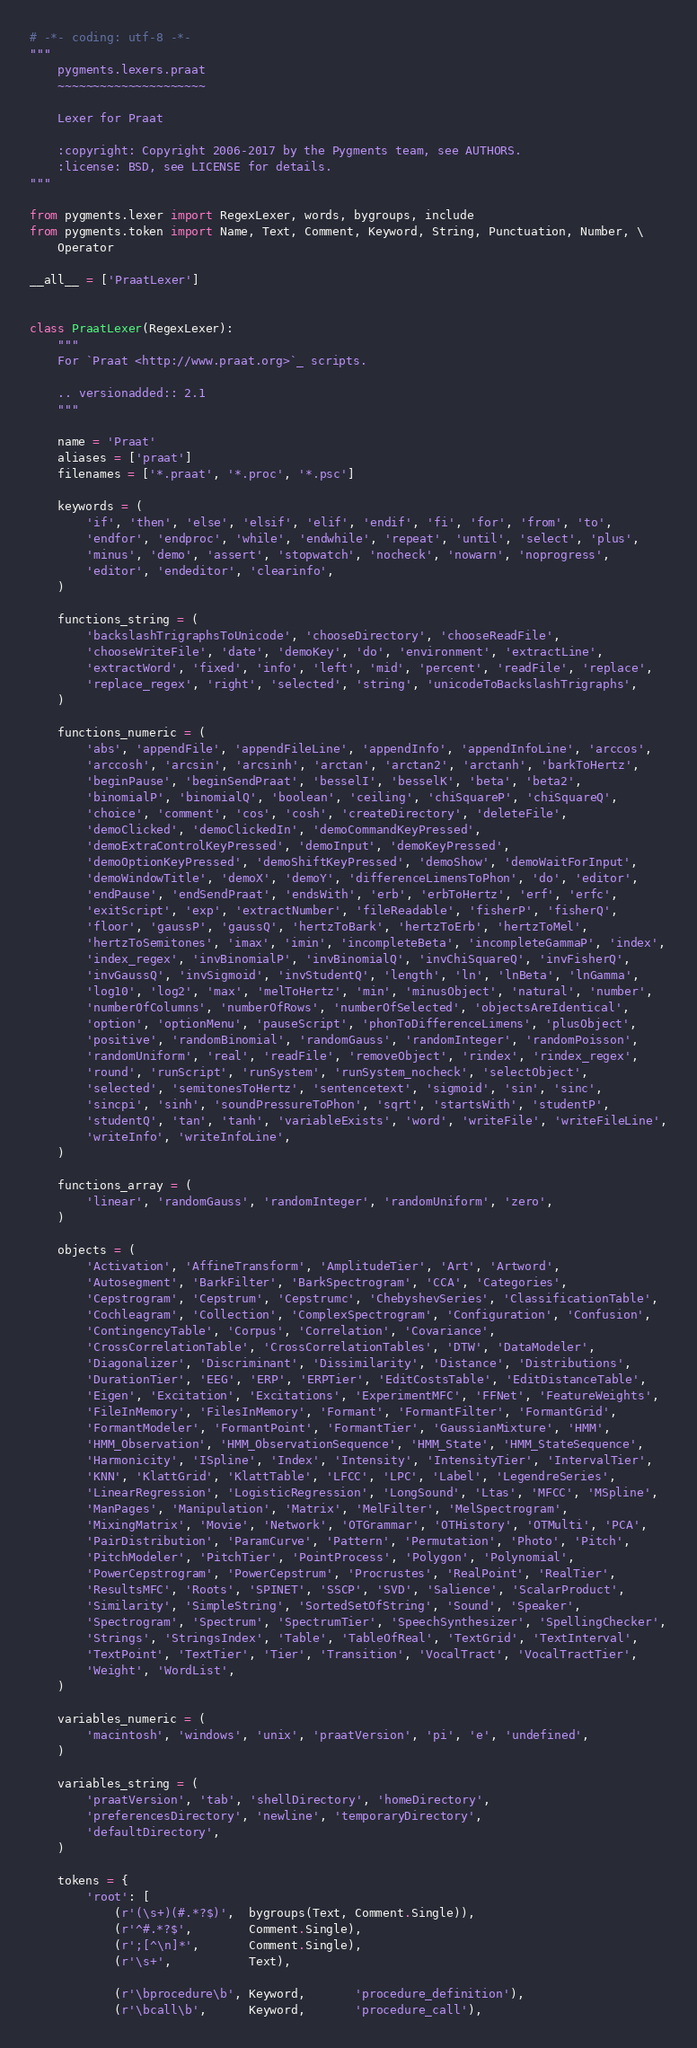Convert code to text. <code><loc_0><loc_0><loc_500><loc_500><_Python_># -*- coding: utf-8 -*-
"""
    pygments.lexers.praat
    ~~~~~~~~~~~~~~~~~~~~~

    Lexer for Praat

    :copyright: Copyright 2006-2017 by the Pygments team, see AUTHORS.
    :license: BSD, see LICENSE for details.
"""

from pygments.lexer import RegexLexer, words, bygroups, include
from pygments.token import Name, Text, Comment, Keyword, String, Punctuation, Number, \
    Operator

__all__ = ['PraatLexer']


class PraatLexer(RegexLexer):
    """
    For `Praat <http://www.praat.org>`_ scripts.

    .. versionadded:: 2.1
    """

    name = 'Praat'
    aliases = ['praat']
    filenames = ['*.praat', '*.proc', '*.psc']

    keywords = (
        'if', 'then', 'else', 'elsif', 'elif', 'endif', 'fi', 'for', 'from', 'to',
        'endfor', 'endproc', 'while', 'endwhile', 'repeat', 'until', 'select', 'plus',
        'minus', 'demo', 'assert', 'stopwatch', 'nocheck', 'nowarn', 'noprogress',
        'editor', 'endeditor', 'clearinfo',
    )

    functions_string = (
        'backslashTrigraphsToUnicode', 'chooseDirectory', 'chooseReadFile',
        'chooseWriteFile', 'date', 'demoKey', 'do', 'environment', 'extractLine',
        'extractWord', 'fixed', 'info', 'left', 'mid', 'percent', 'readFile', 'replace',
        'replace_regex', 'right', 'selected', 'string', 'unicodeToBackslashTrigraphs',
    )

    functions_numeric = (
        'abs', 'appendFile', 'appendFileLine', 'appendInfo', 'appendInfoLine', 'arccos',
        'arccosh', 'arcsin', 'arcsinh', 'arctan', 'arctan2', 'arctanh', 'barkToHertz',
        'beginPause', 'beginSendPraat', 'besselI', 'besselK', 'beta', 'beta2',
        'binomialP', 'binomialQ', 'boolean', 'ceiling', 'chiSquareP', 'chiSquareQ',
        'choice', 'comment', 'cos', 'cosh', 'createDirectory', 'deleteFile',
        'demoClicked', 'demoClickedIn', 'demoCommandKeyPressed',
        'demoExtraControlKeyPressed', 'demoInput', 'demoKeyPressed',
        'demoOptionKeyPressed', 'demoShiftKeyPressed', 'demoShow', 'demoWaitForInput',
        'demoWindowTitle', 'demoX', 'demoY', 'differenceLimensToPhon', 'do', 'editor',
        'endPause', 'endSendPraat', 'endsWith', 'erb', 'erbToHertz', 'erf', 'erfc',
        'exitScript', 'exp', 'extractNumber', 'fileReadable', 'fisherP', 'fisherQ',
        'floor', 'gaussP', 'gaussQ', 'hertzToBark', 'hertzToErb', 'hertzToMel',
        'hertzToSemitones', 'imax', 'imin', 'incompleteBeta', 'incompleteGammaP', 'index',
        'index_regex', 'invBinomialP', 'invBinomialQ', 'invChiSquareQ', 'invFisherQ',
        'invGaussQ', 'invSigmoid', 'invStudentQ', 'length', 'ln', 'lnBeta', 'lnGamma',
        'log10', 'log2', 'max', 'melToHertz', 'min', 'minusObject', 'natural', 'number',
        'numberOfColumns', 'numberOfRows', 'numberOfSelected', 'objectsAreIdentical',
        'option', 'optionMenu', 'pauseScript', 'phonToDifferenceLimens', 'plusObject',
        'positive', 'randomBinomial', 'randomGauss', 'randomInteger', 'randomPoisson',
        'randomUniform', 'real', 'readFile', 'removeObject', 'rindex', 'rindex_regex',
        'round', 'runScript', 'runSystem', 'runSystem_nocheck', 'selectObject',
        'selected', 'semitonesToHertz', 'sentencetext', 'sigmoid', 'sin', 'sinc',
        'sincpi', 'sinh', 'soundPressureToPhon', 'sqrt', 'startsWith', 'studentP',
        'studentQ', 'tan', 'tanh', 'variableExists', 'word', 'writeFile', 'writeFileLine',
        'writeInfo', 'writeInfoLine',
    )

    functions_array = (
        'linear', 'randomGauss', 'randomInteger', 'randomUniform', 'zero',
    )

    objects = (
        'Activation', 'AffineTransform', 'AmplitudeTier', 'Art', 'Artword',
        'Autosegment', 'BarkFilter', 'BarkSpectrogram', 'CCA', 'Categories',
        'Cepstrogram', 'Cepstrum', 'Cepstrumc', 'ChebyshevSeries', 'ClassificationTable',
        'Cochleagram', 'Collection', 'ComplexSpectrogram', 'Configuration', 'Confusion',
        'ContingencyTable', 'Corpus', 'Correlation', 'Covariance',
        'CrossCorrelationTable', 'CrossCorrelationTables', 'DTW', 'DataModeler',
        'Diagonalizer', 'Discriminant', 'Dissimilarity', 'Distance', 'Distributions',
        'DurationTier', 'EEG', 'ERP', 'ERPTier', 'EditCostsTable', 'EditDistanceTable',
        'Eigen', 'Excitation', 'Excitations', 'ExperimentMFC', 'FFNet', 'FeatureWeights',
        'FileInMemory', 'FilesInMemory', 'Formant', 'FormantFilter', 'FormantGrid',
        'FormantModeler', 'FormantPoint', 'FormantTier', 'GaussianMixture', 'HMM',
        'HMM_Observation', 'HMM_ObservationSequence', 'HMM_State', 'HMM_StateSequence',
        'Harmonicity', 'ISpline', 'Index', 'Intensity', 'IntensityTier', 'IntervalTier',
        'KNN', 'KlattGrid', 'KlattTable', 'LFCC', 'LPC', 'Label', 'LegendreSeries',
        'LinearRegression', 'LogisticRegression', 'LongSound', 'Ltas', 'MFCC', 'MSpline',
        'ManPages', 'Manipulation', 'Matrix', 'MelFilter', 'MelSpectrogram',
        'MixingMatrix', 'Movie', 'Network', 'OTGrammar', 'OTHistory', 'OTMulti', 'PCA',
        'PairDistribution', 'ParamCurve', 'Pattern', 'Permutation', 'Photo', 'Pitch',
        'PitchModeler', 'PitchTier', 'PointProcess', 'Polygon', 'Polynomial',
        'PowerCepstrogram', 'PowerCepstrum', 'Procrustes', 'RealPoint', 'RealTier',
        'ResultsMFC', 'Roots', 'SPINET', 'SSCP', 'SVD', 'Salience', 'ScalarProduct',
        'Similarity', 'SimpleString', 'SortedSetOfString', 'Sound', 'Speaker',
        'Spectrogram', 'Spectrum', 'SpectrumTier', 'SpeechSynthesizer', 'SpellingChecker',
        'Strings', 'StringsIndex', 'Table', 'TableOfReal', 'TextGrid', 'TextInterval',
        'TextPoint', 'TextTier', 'Tier', 'Transition', 'VocalTract', 'VocalTractTier',
        'Weight', 'WordList',
    )

    variables_numeric = (
        'macintosh', 'windows', 'unix', 'praatVersion', 'pi', 'e', 'undefined',
    )

    variables_string = (
        'praatVersion', 'tab', 'shellDirectory', 'homeDirectory',
        'preferencesDirectory', 'newline', 'temporaryDirectory',
        'defaultDirectory',
    )

    tokens = {
        'root': [
            (r'(\s+)(#.*?$)',  bygroups(Text, Comment.Single)),
            (r'^#.*?$',        Comment.Single),
            (r';[^\n]*',       Comment.Single),
            (r'\s+',           Text),

            (r'\bprocedure\b', Keyword,       'procedure_definition'),
            (r'\bcall\b',      Keyword,       'procedure_call'),</code> 